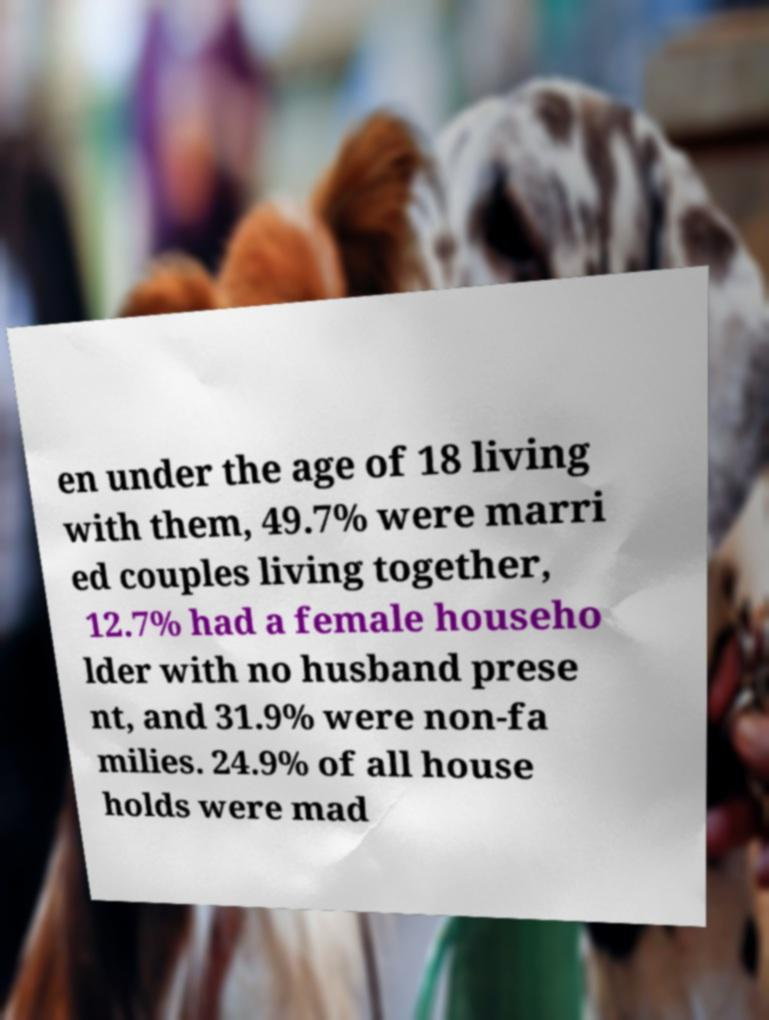Could you assist in decoding the text presented in this image and type it out clearly? en under the age of 18 living with them, 49.7% were marri ed couples living together, 12.7% had a female househo lder with no husband prese nt, and 31.9% were non-fa milies. 24.9% of all house holds were mad 